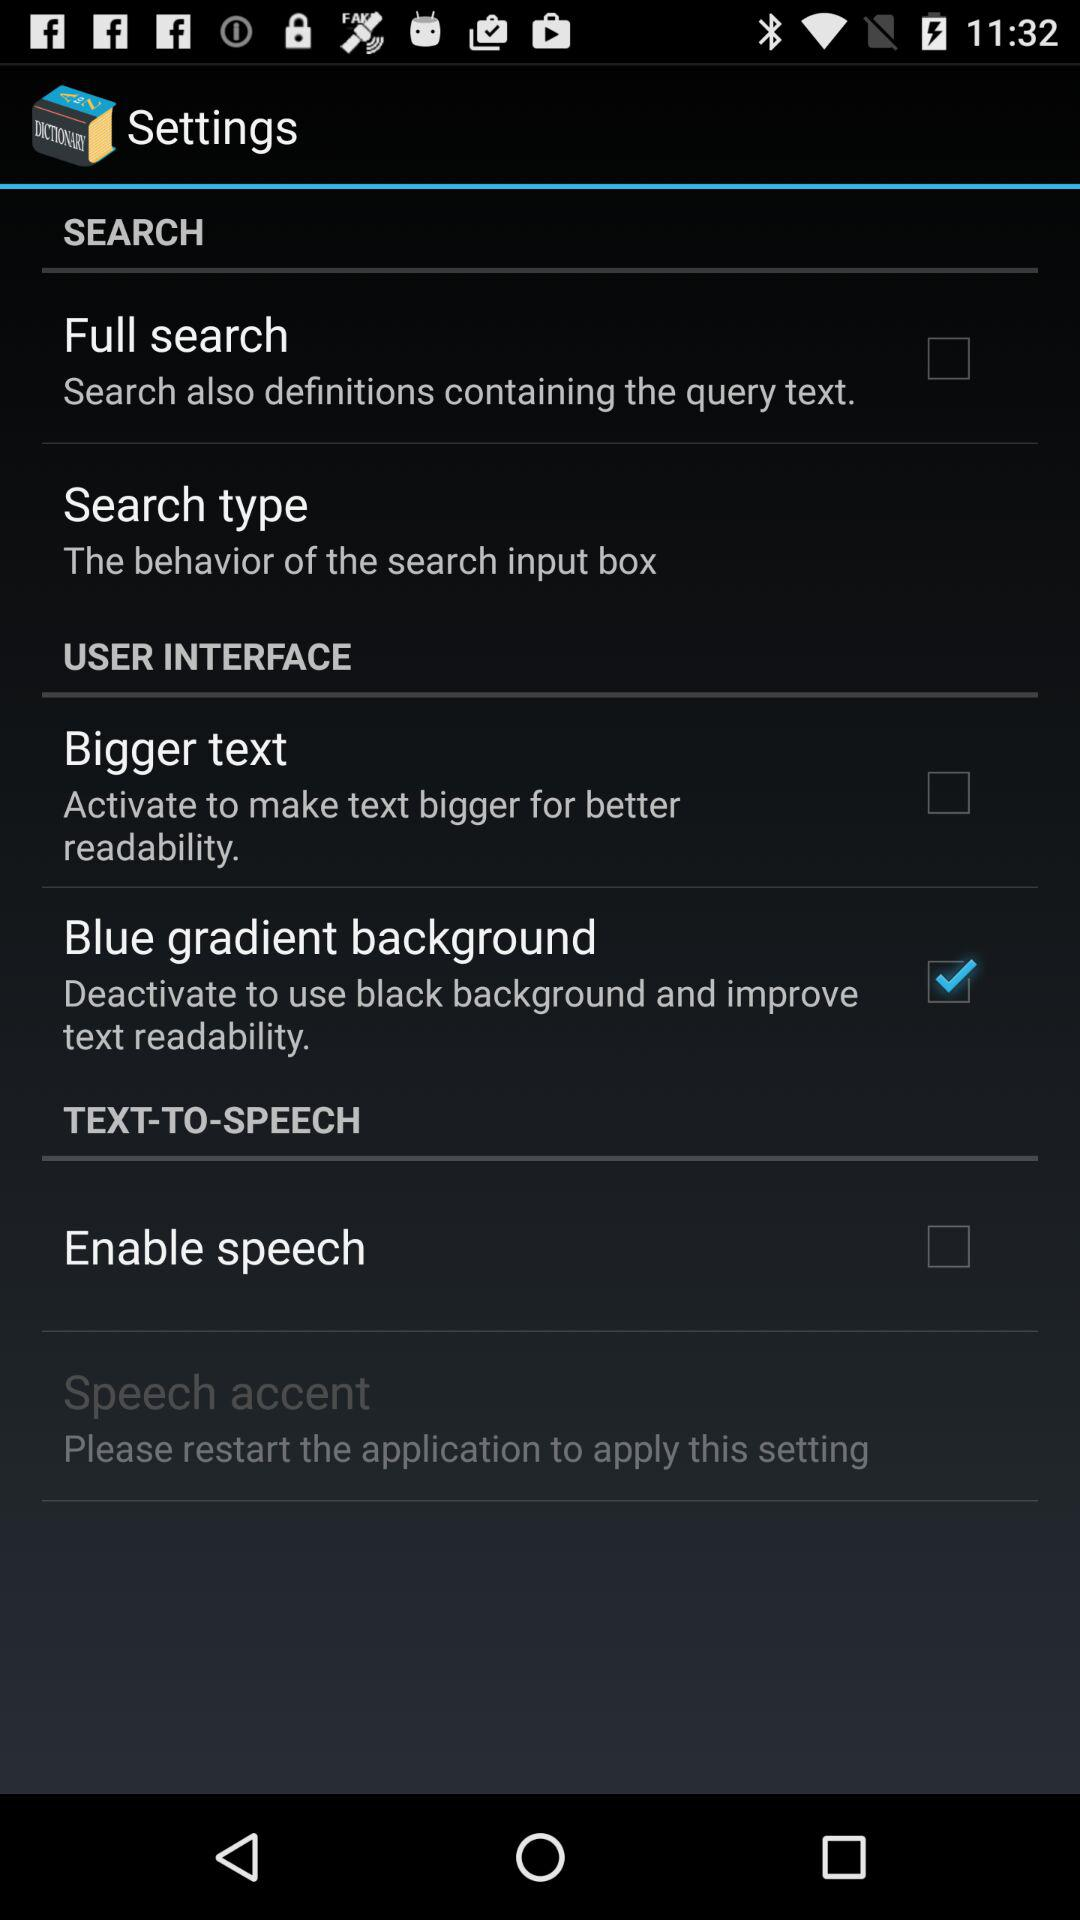How many settings options are there for text-to-speech?
Answer the question using a single word or phrase. 2 